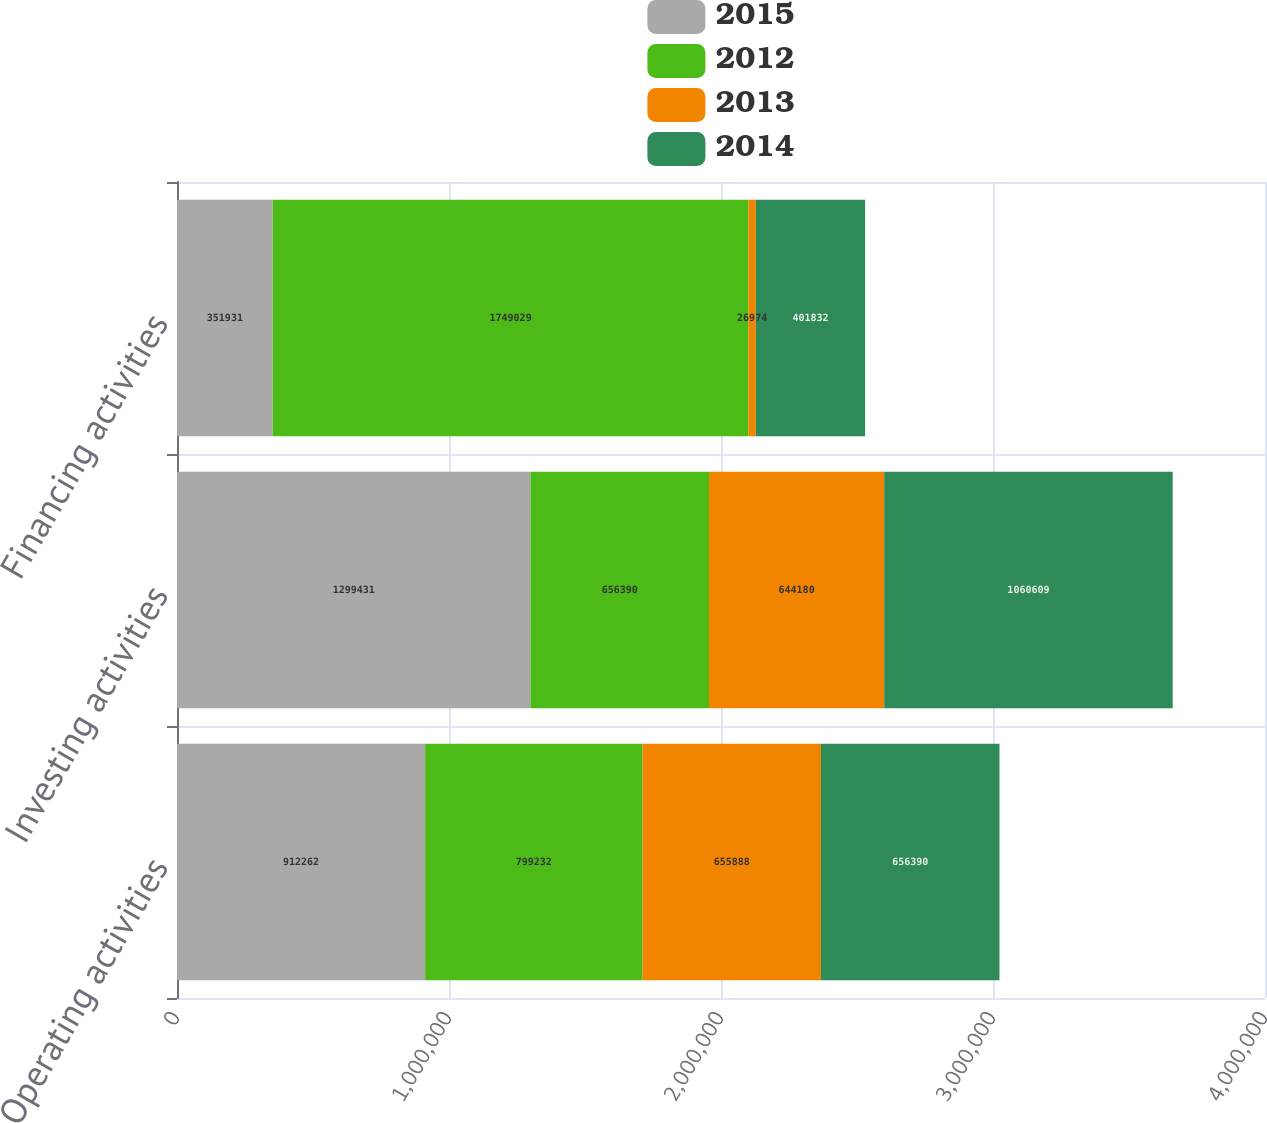Convert chart to OTSL. <chart><loc_0><loc_0><loc_500><loc_500><stacked_bar_chart><ecel><fcel>Operating activities<fcel>Investing activities<fcel>Financing activities<nl><fcel>2015<fcel>912262<fcel>1.29943e+06<fcel>351931<nl><fcel>2012<fcel>799232<fcel>656390<fcel>1.74903e+06<nl><fcel>2013<fcel>655888<fcel>644180<fcel>26974<nl><fcel>2014<fcel>656390<fcel>1.06061e+06<fcel>401832<nl></chart> 